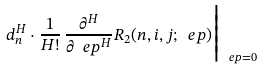<formula> <loc_0><loc_0><loc_500><loc_500>d _ { n } ^ { H } \cdot \frac { 1 } { H ! } \, \frac { \partial ^ { H } } { \partial \ e p ^ { H } } R _ { 2 } ( n , i , j ; \ e p ) \Big | _ { \ e p = 0 }</formula> 